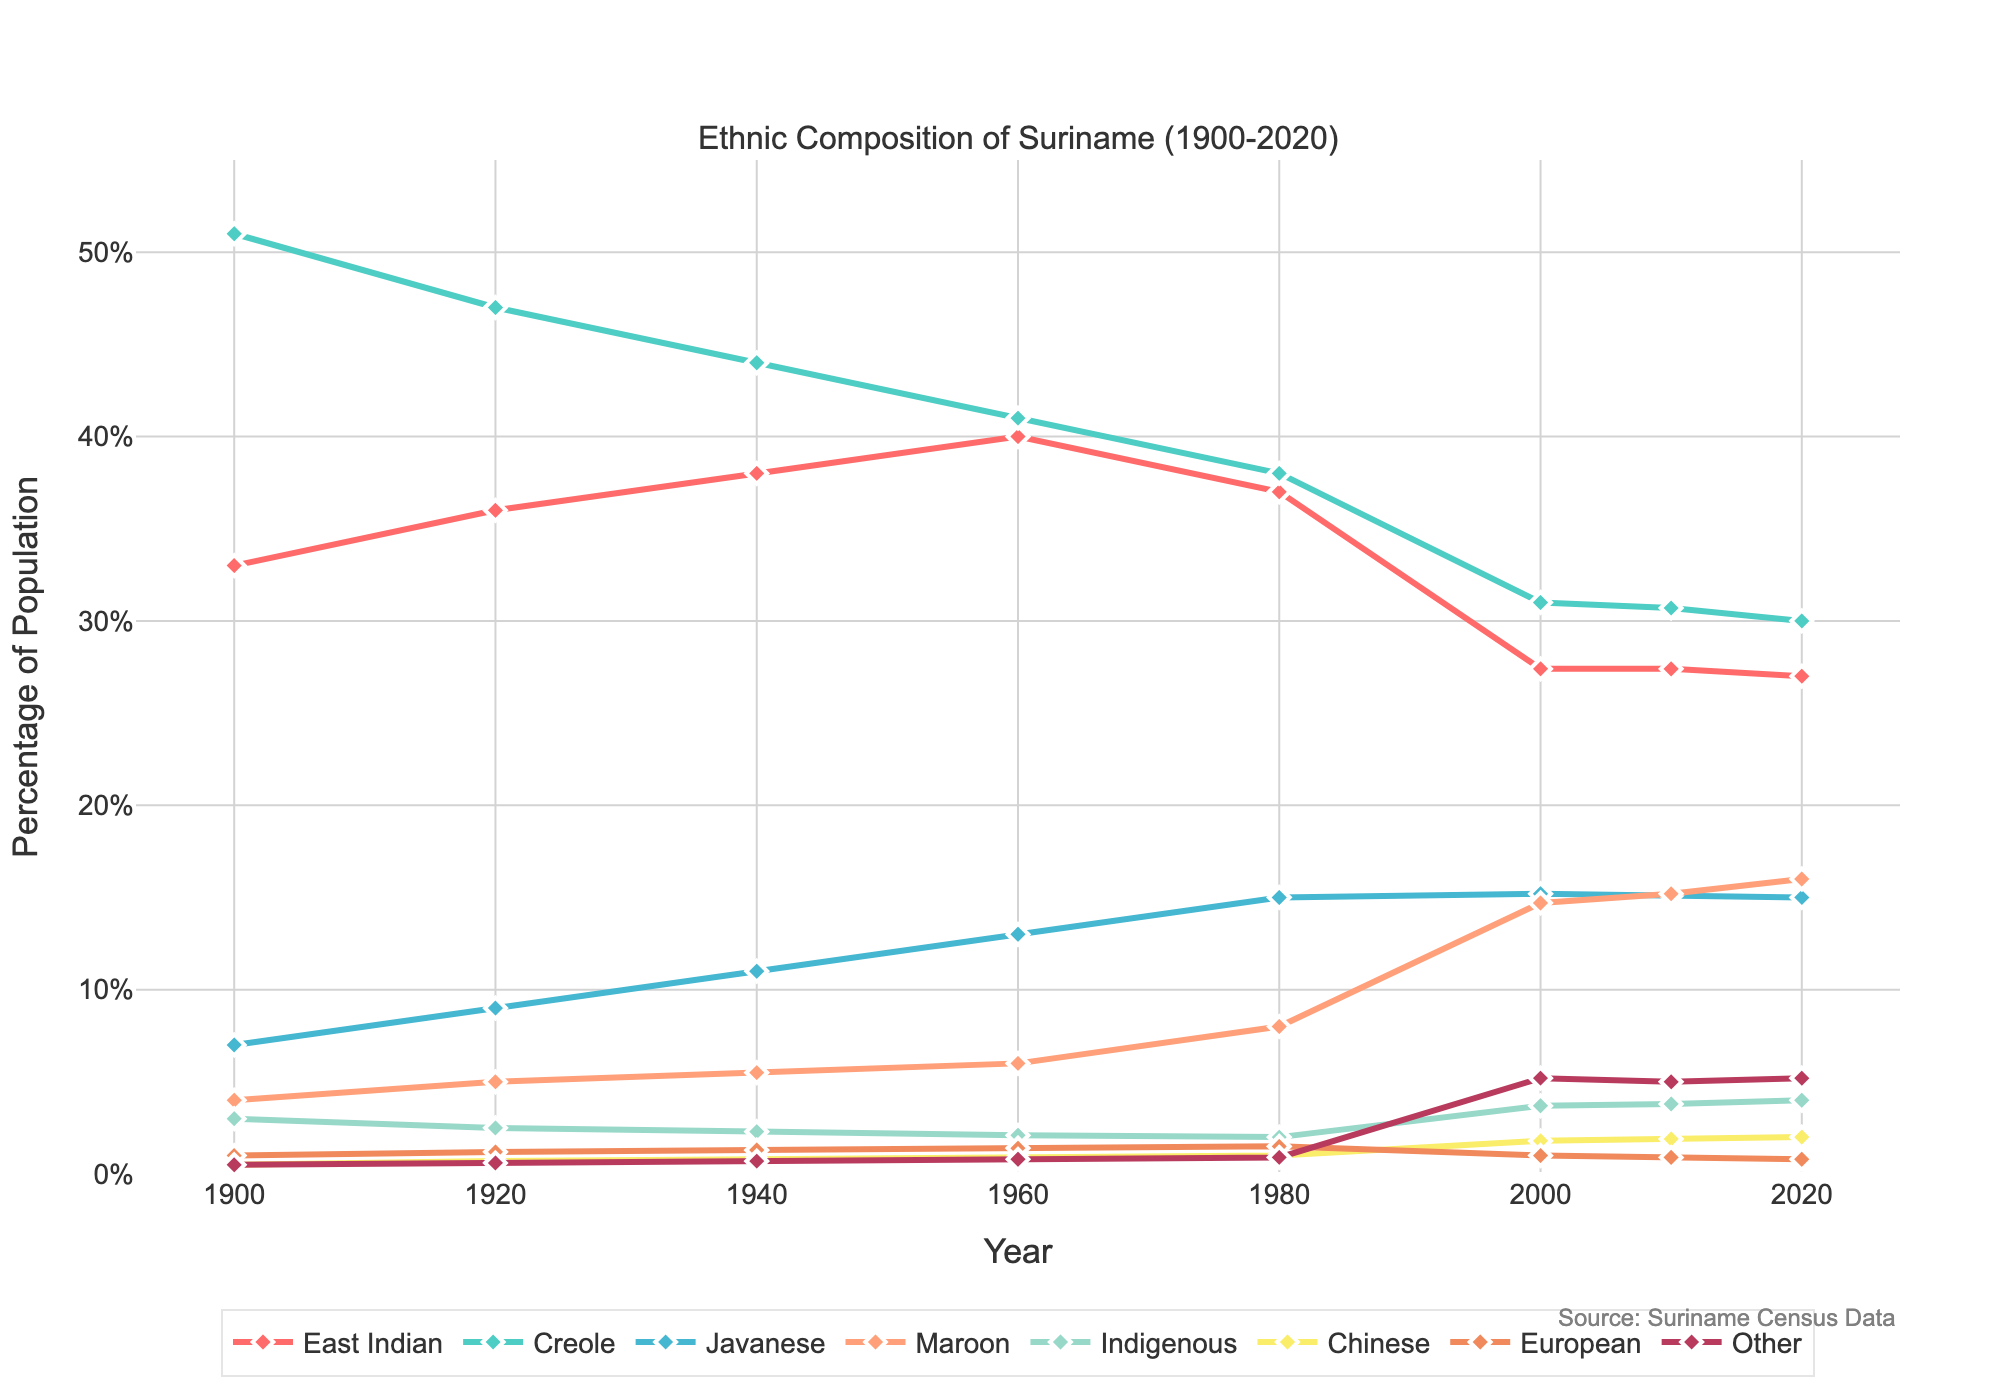What ethnic group had the highest percentage in 1900? By looking at the figure at the year 1900, we can see that Creole had the highest percentage.
Answer: Creole Which ethnic group's percentage remained constant from 2000 to 2020? By observing the figure from 2000 to 2020, we notice that East Indian's percentage remained around 27%, indicating it is constant.
Answer: East Indian What is the percentage difference between Creole and Maroon in 2020? In 2020, Creole is at 30% and Maroon is at 16%. The difference is 30% - 16% = 14%.
Answer: 14% Which ethnic group showed the most significant increase from 1900 to 2020? Comparing all ethnic groups from 1900 to 2020, Maroon increased from 4% to 16%, the most significant rise of 12 percentage points.
Answer: Maroon What is the average percentage of Javanese from 1900 to 2020? Adding the Javanese percentages: 7 + 9 + 11 + 13 + 15 + 15.2 + 15.1 + 15 = 100.3. Then, divide by the number of data points: 100.3 / 8 = 12.54%.
Answer: 12.54% Which ethnic group decreased in percentage from 1960 to 2000? By comparing percentages from 1960 (40%) to 2000 (27.4%), East Indian shows a decrease.
Answer: East Indian In which year did the Indigenous population percentage peak according to the figure? From the figure, it is observed that the Indigenous population percentage peaked in 2020.
Answer: 2020 What was the trend of the Creole population from 1900 to 2020? By observing the line corresponding to Creole, we see a steady decline over time from 51% in 1900 to 30% in 2020.
Answer: Decline Which year saw a significant rise in the 'Other' category of the population? The 'Other' category saw a noticeable rise around the year 2000, marking a significant increase compared to previous years.
Answer: 2000 